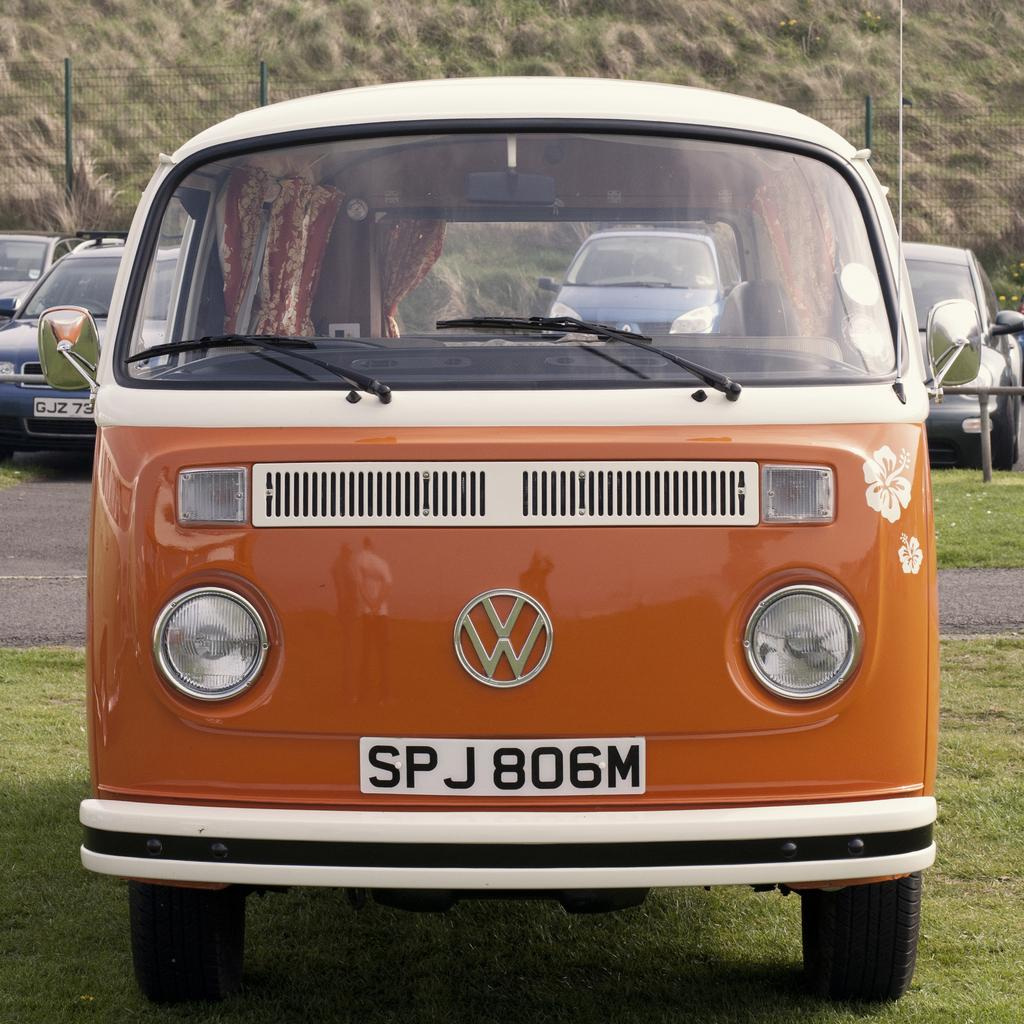<image>
Render a clear and concise summary of the photo. front of an orange bus made by volkswagon auto 